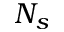<formula> <loc_0><loc_0><loc_500><loc_500>N _ { s }</formula> 